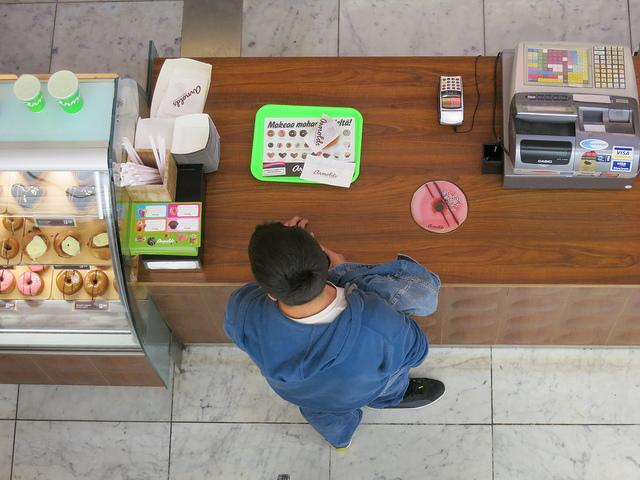Who is the man waiting for? cashier 